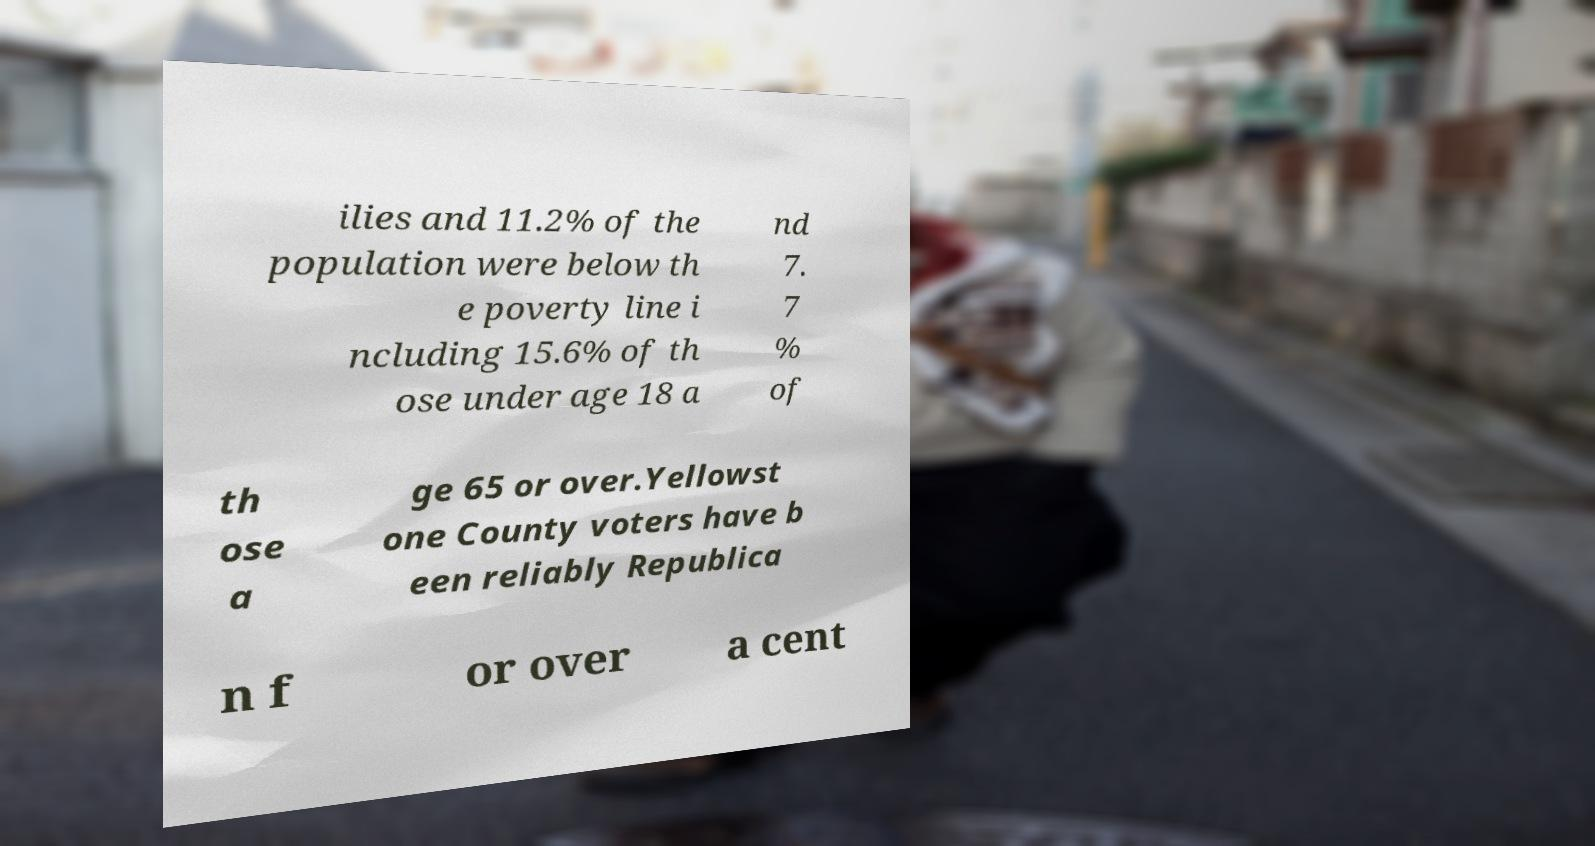What messages or text are displayed in this image? I need them in a readable, typed format. ilies and 11.2% of the population were below th e poverty line i ncluding 15.6% of th ose under age 18 a nd 7. 7 % of th ose a ge 65 or over.Yellowst one County voters have b een reliably Republica n f or over a cent 